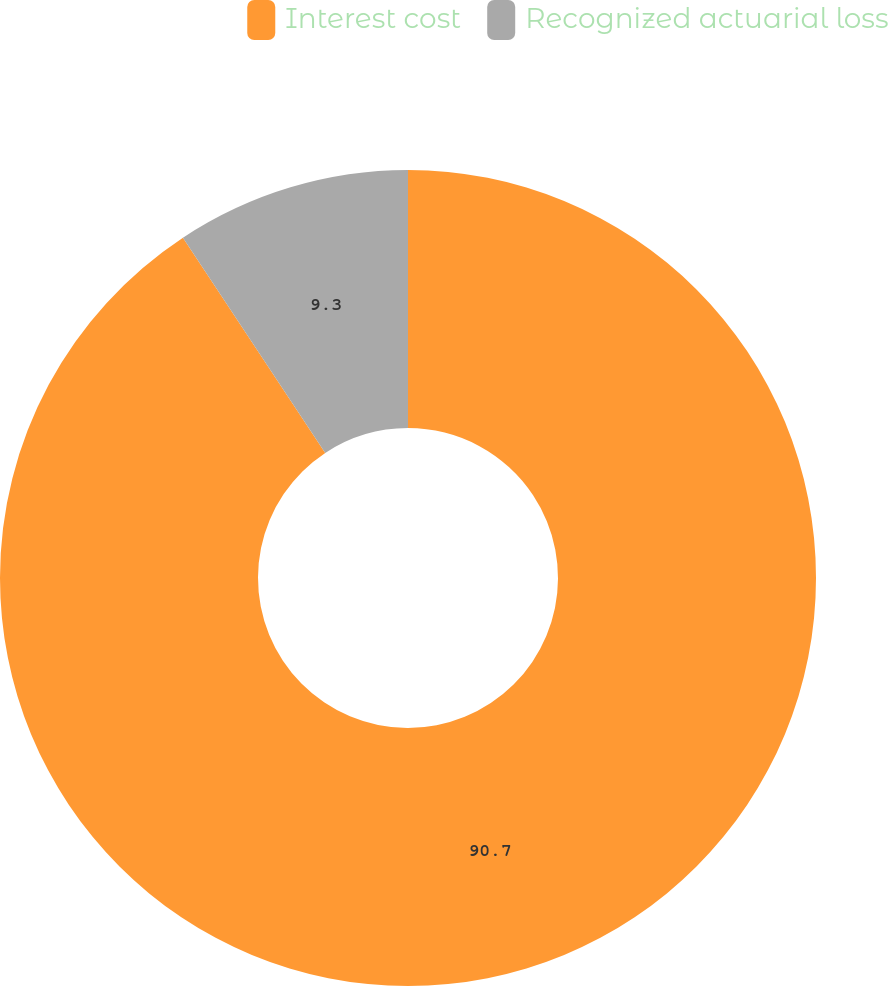Convert chart to OTSL. <chart><loc_0><loc_0><loc_500><loc_500><pie_chart><fcel>Interest cost<fcel>Recognized actuarial loss<nl><fcel>90.7%<fcel>9.3%<nl></chart> 